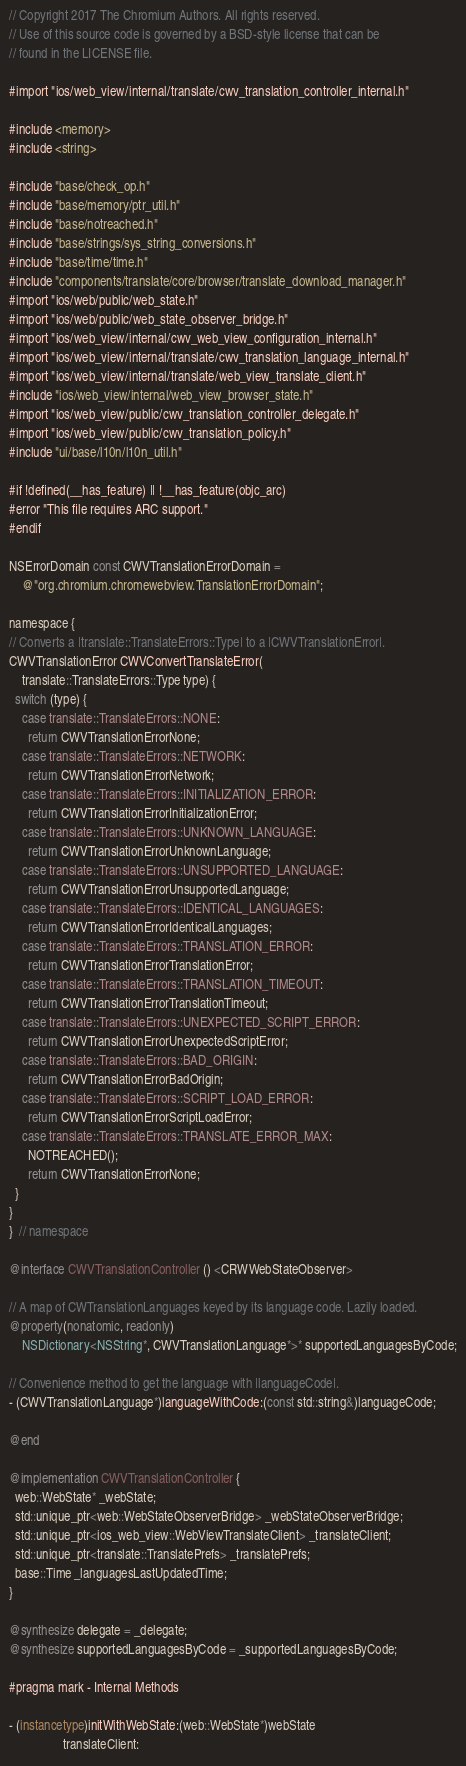Convert code to text. <code><loc_0><loc_0><loc_500><loc_500><_ObjectiveC_>// Copyright 2017 The Chromium Authors. All rights reserved.
// Use of this source code is governed by a BSD-style license that can be
// found in the LICENSE file.

#import "ios/web_view/internal/translate/cwv_translation_controller_internal.h"

#include <memory>
#include <string>

#include "base/check_op.h"
#include "base/memory/ptr_util.h"
#include "base/notreached.h"
#include "base/strings/sys_string_conversions.h"
#include "base/time/time.h"
#include "components/translate/core/browser/translate_download_manager.h"
#import "ios/web/public/web_state.h"
#import "ios/web/public/web_state_observer_bridge.h"
#import "ios/web_view/internal/cwv_web_view_configuration_internal.h"
#import "ios/web_view/internal/translate/cwv_translation_language_internal.h"
#import "ios/web_view/internal/translate/web_view_translate_client.h"
#include "ios/web_view/internal/web_view_browser_state.h"
#import "ios/web_view/public/cwv_translation_controller_delegate.h"
#import "ios/web_view/public/cwv_translation_policy.h"
#include "ui/base/l10n/l10n_util.h"

#if !defined(__has_feature) || !__has_feature(objc_arc)
#error "This file requires ARC support."
#endif

NSErrorDomain const CWVTranslationErrorDomain =
    @"org.chromium.chromewebview.TranslationErrorDomain";

namespace {
// Converts a |translate::TranslateErrors::Type| to a |CWVTranslationError|.
CWVTranslationError CWVConvertTranslateError(
    translate::TranslateErrors::Type type) {
  switch (type) {
    case translate::TranslateErrors::NONE:
      return CWVTranslationErrorNone;
    case translate::TranslateErrors::NETWORK:
      return CWVTranslationErrorNetwork;
    case translate::TranslateErrors::INITIALIZATION_ERROR:
      return CWVTranslationErrorInitializationError;
    case translate::TranslateErrors::UNKNOWN_LANGUAGE:
      return CWVTranslationErrorUnknownLanguage;
    case translate::TranslateErrors::UNSUPPORTED_LANGUAGE:
      return CWVTranslationErrorUnsupportedLanguage;
    case translate::TranslateErrors::IDENTICAL_LANGUAGES:
      return CWVTranslationErrorIdenticalLanguages;
    case translate::TranslateErrors::TRANSLATION_ERROR:
      return CWVTranslationErrorTranslationError;
    case translate::TranslateErrors::TRANSLATION_TIMEOUT:
      return CWVTranslationErrorTranslationTimeout;
    case translate::TranslateErrors::UNEXPECTED_SCRIPT_ERROR:
      return CWVTranslationErrorUnexpectedScriptError;
    case translate::TranslateErrors::BAD_ORIGIN:
      return CWVTranslationErrorBadOrigin;
    case translate::TranslateErrors::SCRIPT_LOAD_ERROR:
      return CWVTranslationErrorScriptLoadError;
    case translate::TranslateErrors::TRANSLATE_ERROR_MAX:
      NOTREACHED();
      return CWVTranslationErrorNone;
  }
}
}  // namespace

@interface CWVTranslationController () <CRWWebStateObserver>

// A map of CWTranslationLanguages keyed by its language code. Lazily loaded.
@property(nonatomic, readonly)
    NSDictionary<NSString*, CWVTranslationLanguage*>* supportedLanguagesByCode;

// Convenience method to get the language with |languageCode|.
- (CWVTranslationLanguage*)languageWithCode:(const std::string&)languageCode;

@end

@implementation CWVTranslationController {
  web::WebState* _webState;
  std::unique_ptr<web::WebStateObserverBridge> _webStateObserverBridge;
  std::unique_ptr<ios_web_view::WebViewTranslateClient> _translateClient;
  std::unique_ptr<translate::TranslatePrefs> _translatePrefs;
  base::Time _languagesLastUpdatedTime;
}

@synthesize delegate = _delegate;
@synthesize supportedLanguagesByCode = _supportedLanguagesByCode;

#pragma mark - Internal Methods

- (instancetype)initWithWebState:(web::WebState*)webState
                 translateClient:</code> 